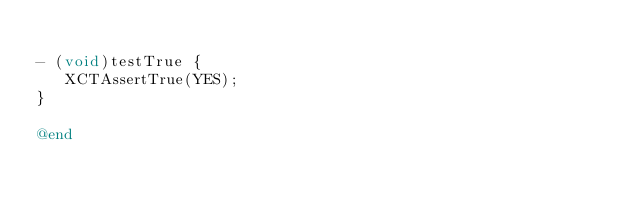<code> <loc_0><loc_0><loc_500><loc_500><_ObjectiveC_>
- (void)testTrue {
   XCTAssertTrue(YES);
}

@end
</code> 